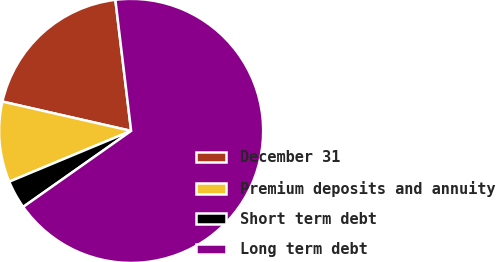<chart> <loc_0><loc_0><loc_500><loc_500><pie_chart><fcel>December 31<fcel>Premium deposits and annuity<fcel>Short term debt<fcel>Long term debt<nl><fcel>19.53%<fcel>9.85%<fcel>3.48%<fcel>67.14%<nl></chart> 